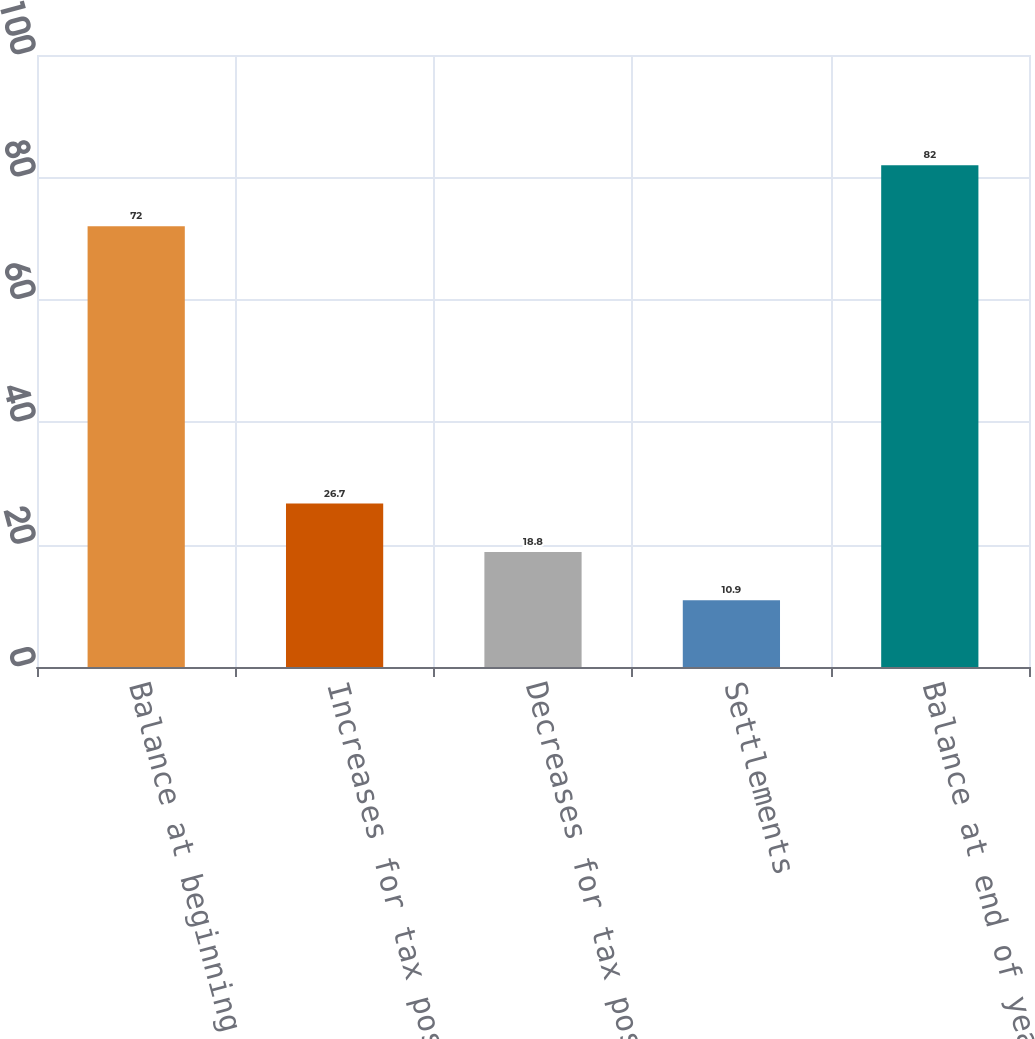<chart> <loc_0><loc_0><loc_500><loc_500><bar_chart><fcel>Balance at beginning of year<fcel>Increases for tax positions<fcel>Decreases for tax positions<fcel>Settlements<fcel>Balance at end of year<nl><fcel>72<fcel>26.7<fcel>18.8<fcel>10.9<fcel>82<nl></chart> 